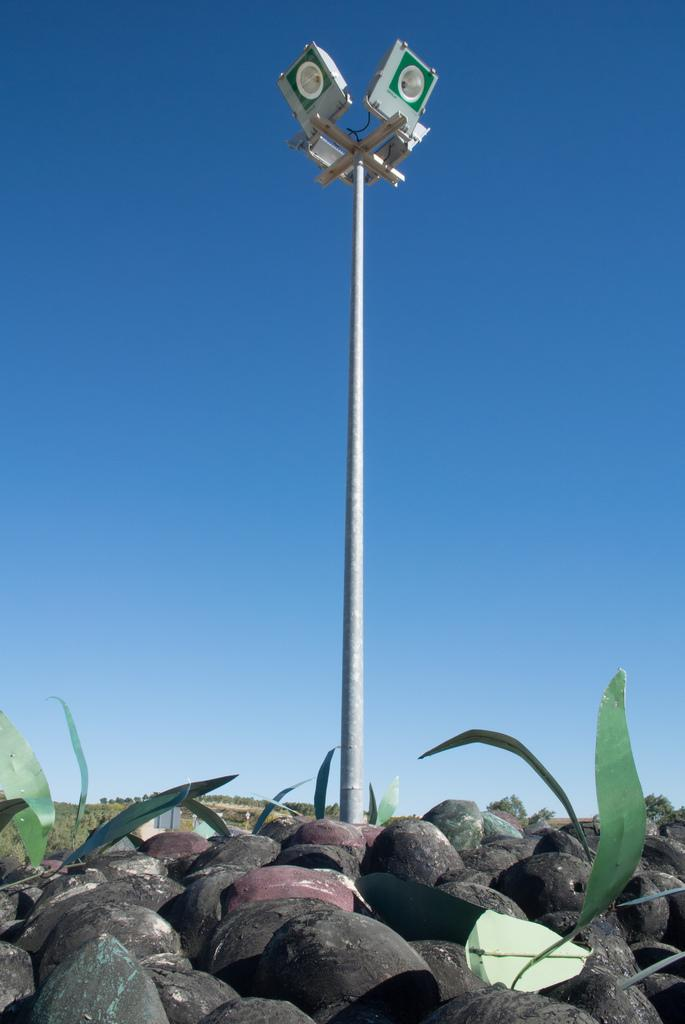What is the main object in the center of the image? There is a pole in the center of the image. What is attached to the pole? Lights are present on the pole. What is visible at the top of the image? The sky is visible at the top of the image. What type of natural elements are present at the bottom of the image? Rocks, trees, and grass are present at the bottom of the image. Can you see the brain of the person who took the picture in the image? There is no brain visible in the image, as it features a pole with lights, the sky, and natural elements at the bottom. 